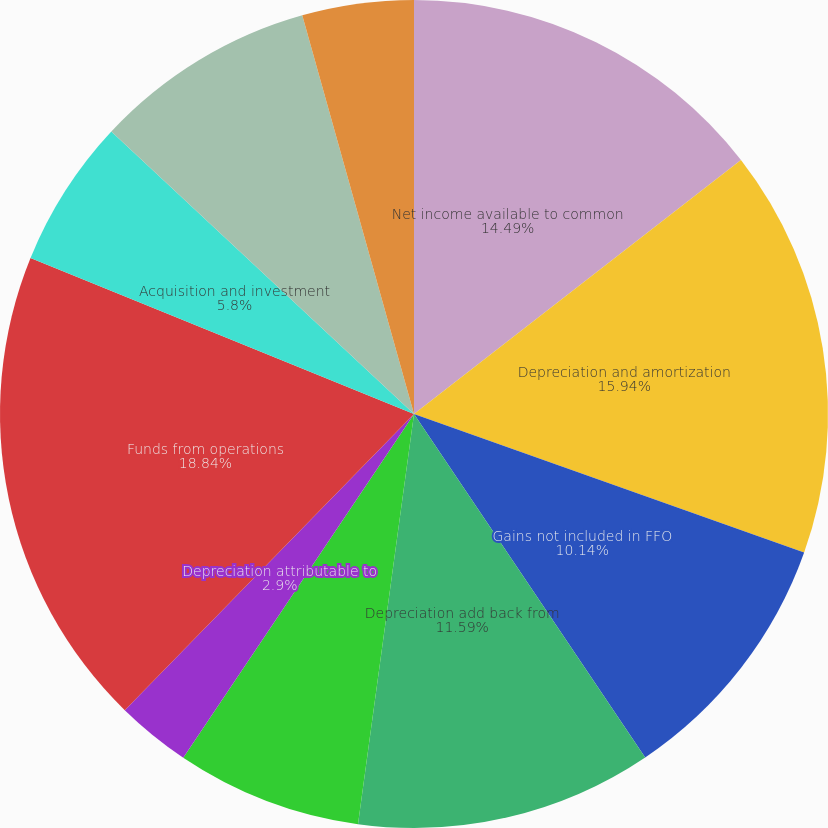Convert chart to OTSL. <chart><loc_0><loc_0><loc_500><loc_500><pie_chart><fcel>Net income available to common<fcel>Depreciation and amortization<fcel>Gains not included in FFO<fcel>Depreciation add back from<fcel>Noncontrolling interest<fcel>Depreciation attributable to<fcel>Funds from operations<fcel>Acquisition and investment<fcel>Gain on sale of marketable<fcel>Loss on early retirement of<nl><fcel>14.49%<fcel>15.94%<fcel>10.14%<fcel>11.59%<fcel>7.25%<fcel>2.9%<fcel>18.84%<fcel>5.8%<fcel>8.7%<fcel>4.35%<nl></chart> 